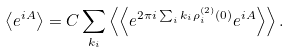Convert formula to latex. <formula><loc_0><loc_0><loc_500><loc_500>\left \langle e ^ { i A } \right \rangle = C \sum _ { k _ { i } } \left \langle \left \langle e ^ { 2 \pi i \sum _ { i } k _ { i } \rho _ { i } ^ { \left ( 2 \right ) } \left ( 0 \right ) } e ^ { i A } \right \rangle \right \rangle .</formula> 